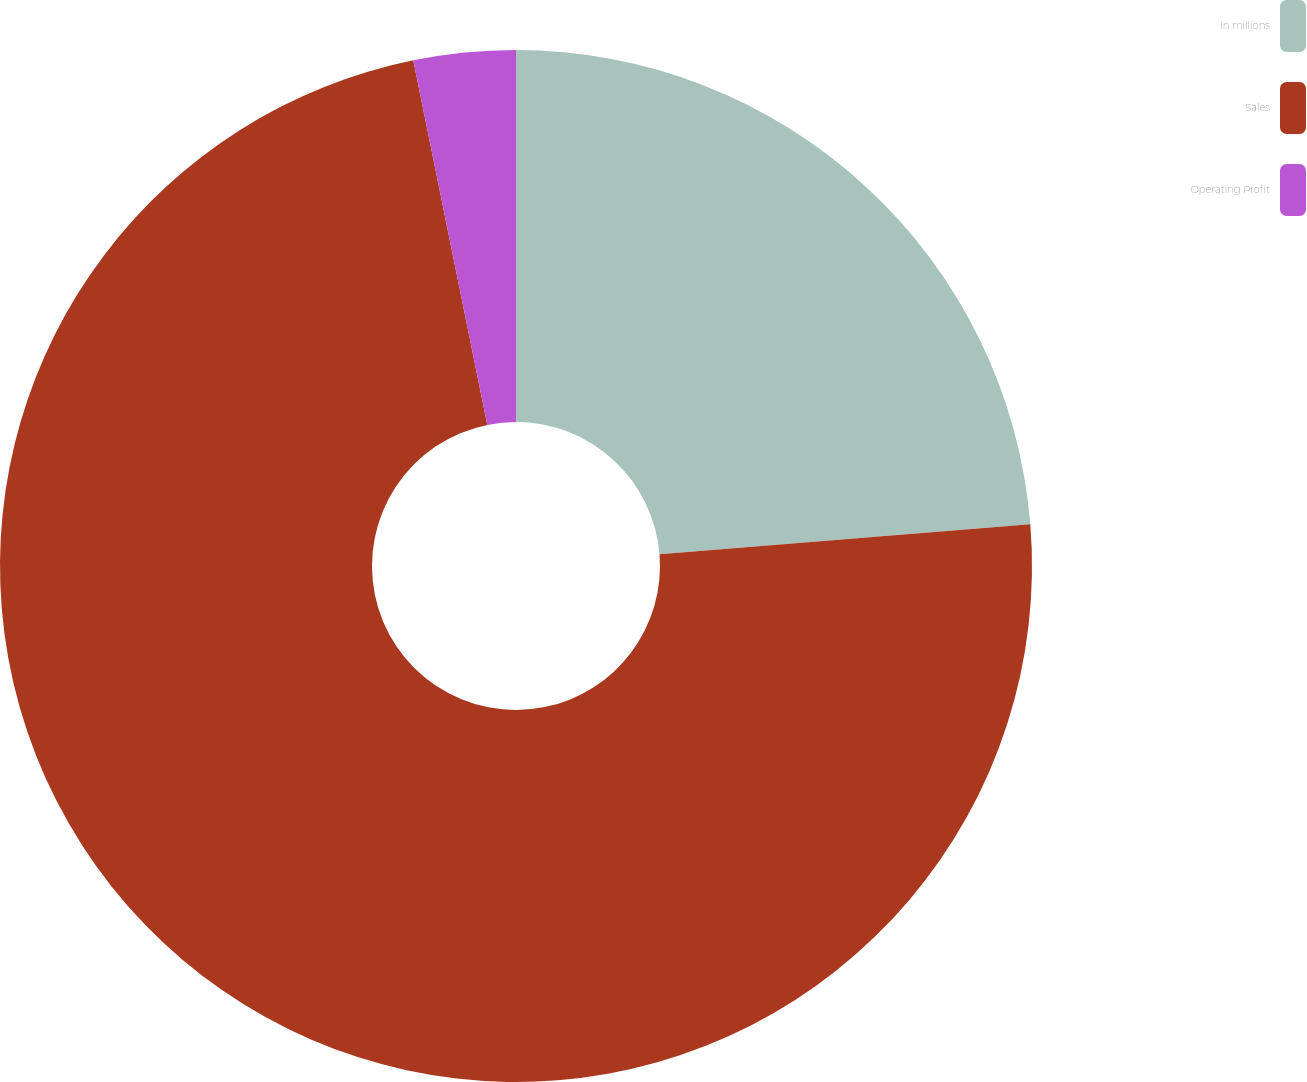Convert chart to OTSL. <chart><loc_0><loc_0><loc_500><loc_500><pie_chart><fcel>In millions<fcel>Sales<fcel>Operating Profit<nl><fcel>23.71%<fcel>73.09%<fcel>3.19%<nl></chart> 